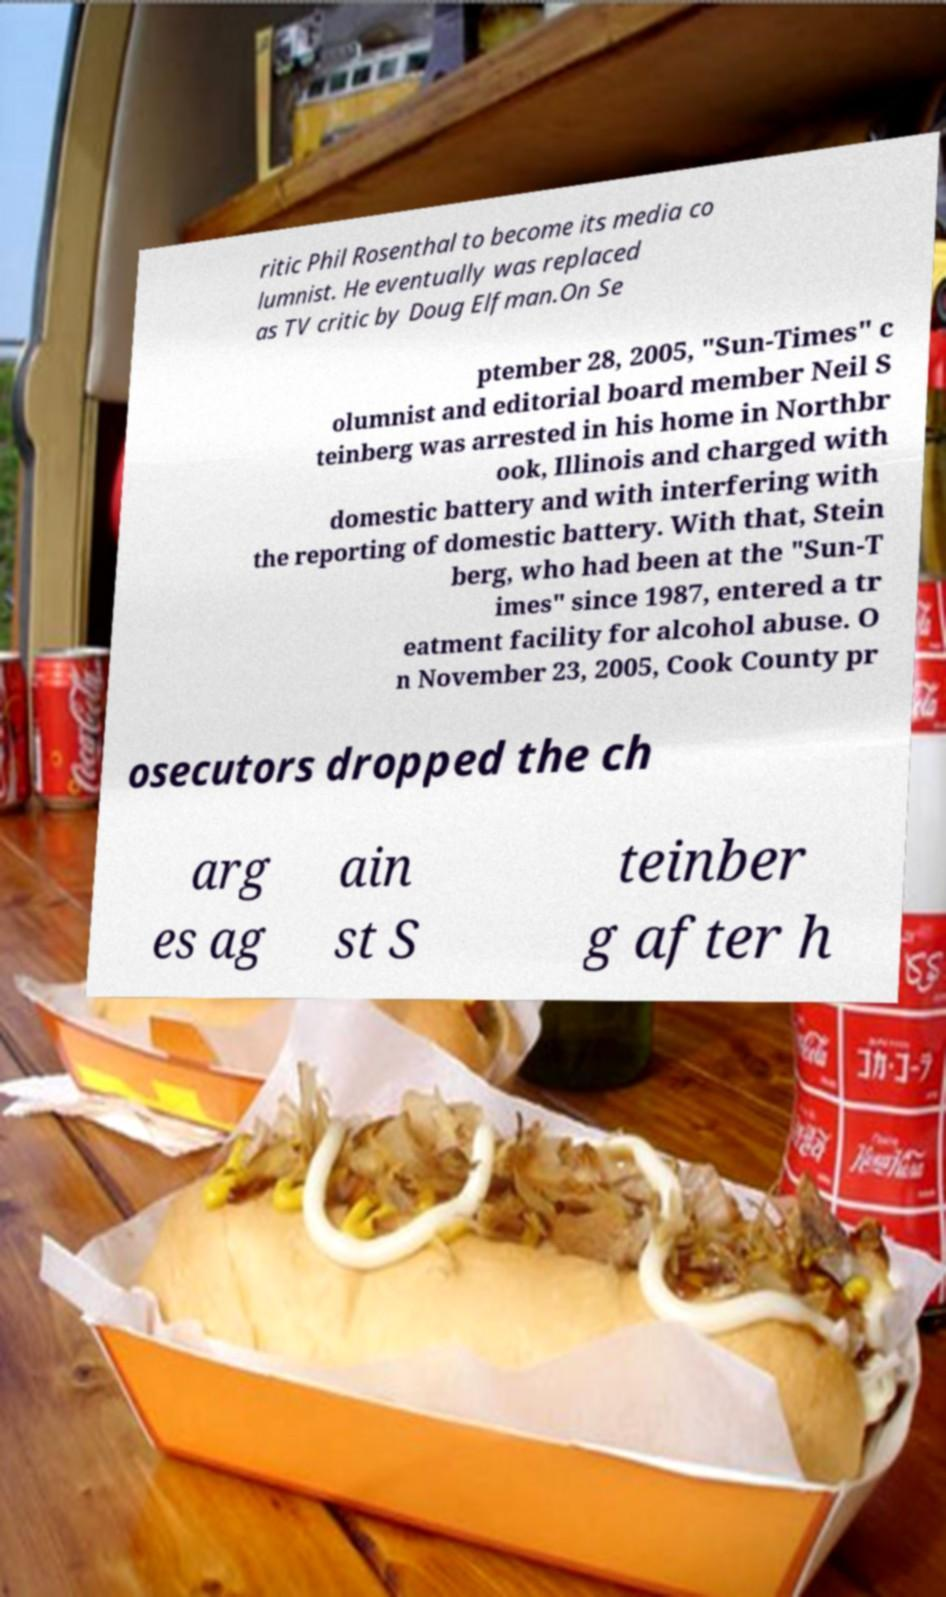For documentation purposes, I need the text within this image transcribed. Could you provide that? ritic Phil Rosenthal to become its media co lumnist. He eventually was replaced as TV critic by Doug Elfman.On Se ptember 28, 2005, "Sun-Times" c olumnist and editorial board member Neil S teinberg was arrested in his home in Northbr ook, Illinois and charged with domestic battery and with interfering with the reporting of domestic battery. With that, Stein berg, who had been at the "Sun-T imes" since 1987, entered a tr eatment facility for alcohol abuse. O n November 23, 2005, Cook County pr osecutors dropped the ch arg es ag ain st S teinber g after h 